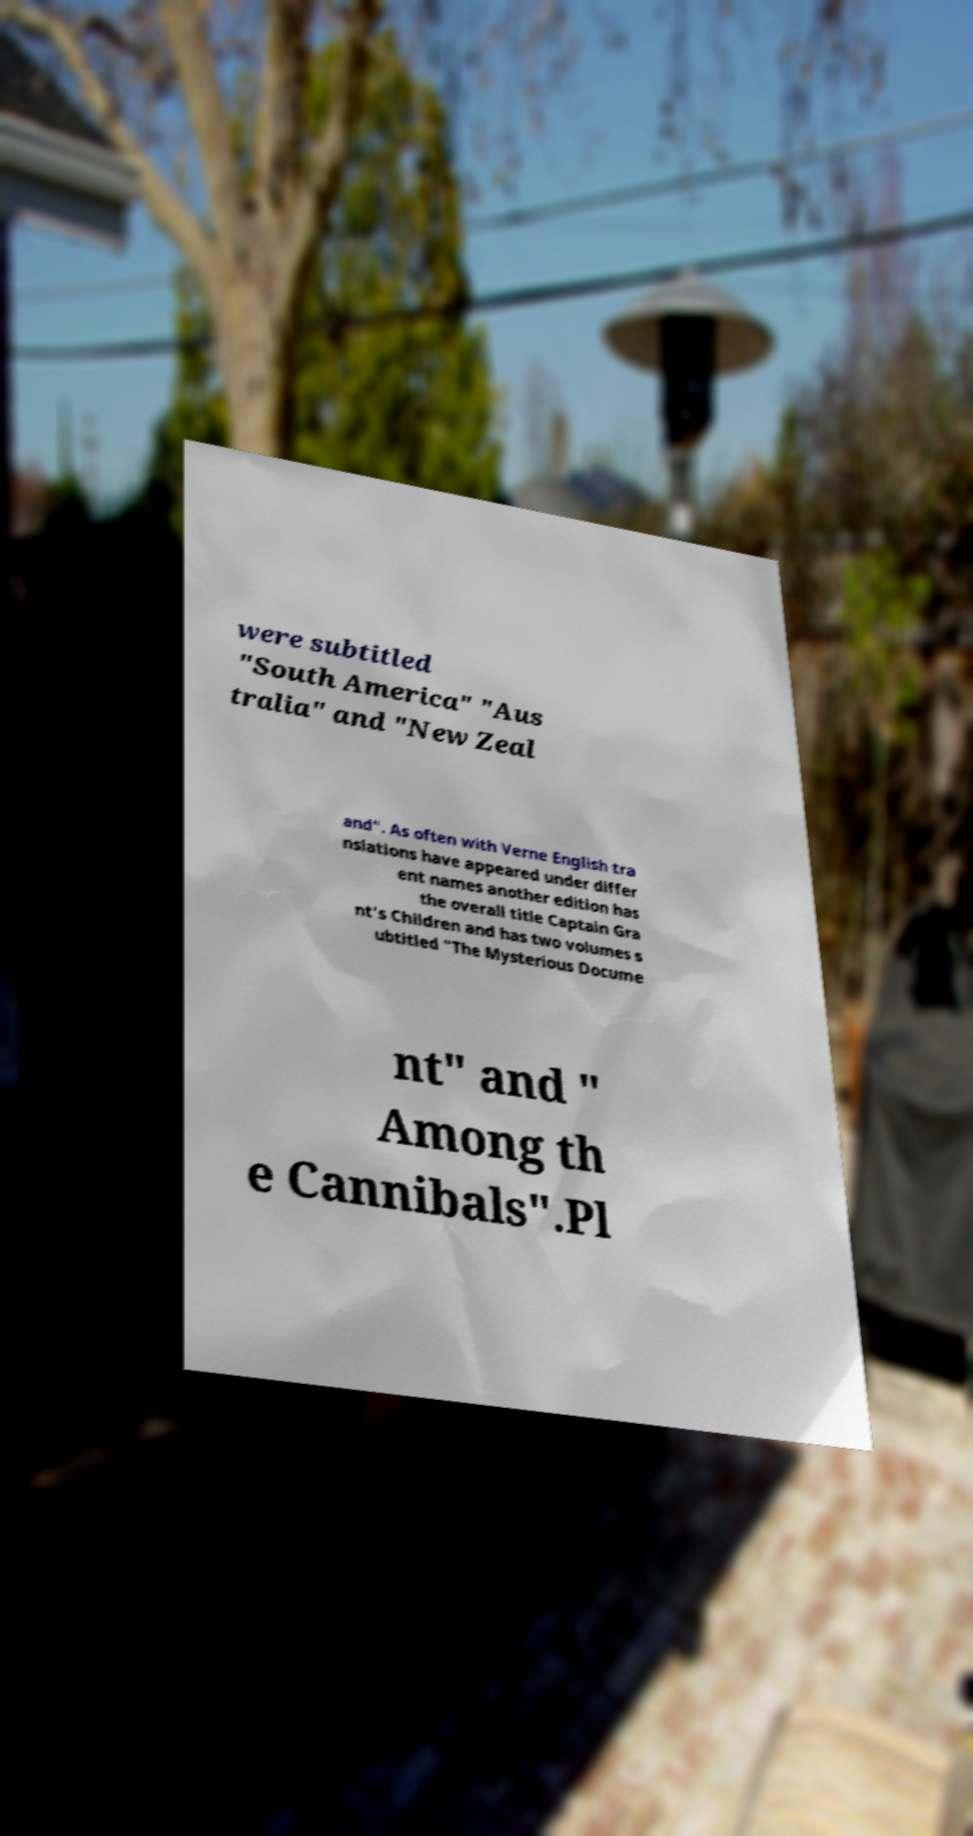I need the written content from this picture converted into text. Can you do that? were subtitled "South America" "Aus tralia" and "New Zeal and". As often with Verne English tra nslations have appeared under differ ent names another edition has the overall title Captain Gra nt's Children and has two volumes s ubtitled "The Mysterious Docume nt" and " Among th e Cannibals".Pl 